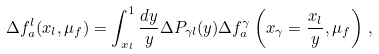<formula> <loc_0><loc_0><loc_500><loc_500>\Delta f _ { a } ^ { l } ( x _ { l } , \mu _ { f } ) = \int _ { x _ { l } } ^ { 1 } \frac { d y } { y } \Delta P _ { \gamma l } ( y ) \Delta f _ { a } ^ { \gamma } \left ( x _ { \gamma } = \frac { x _ { l } } { y } , \mu _ { f } \right ) \, ,</formula> 